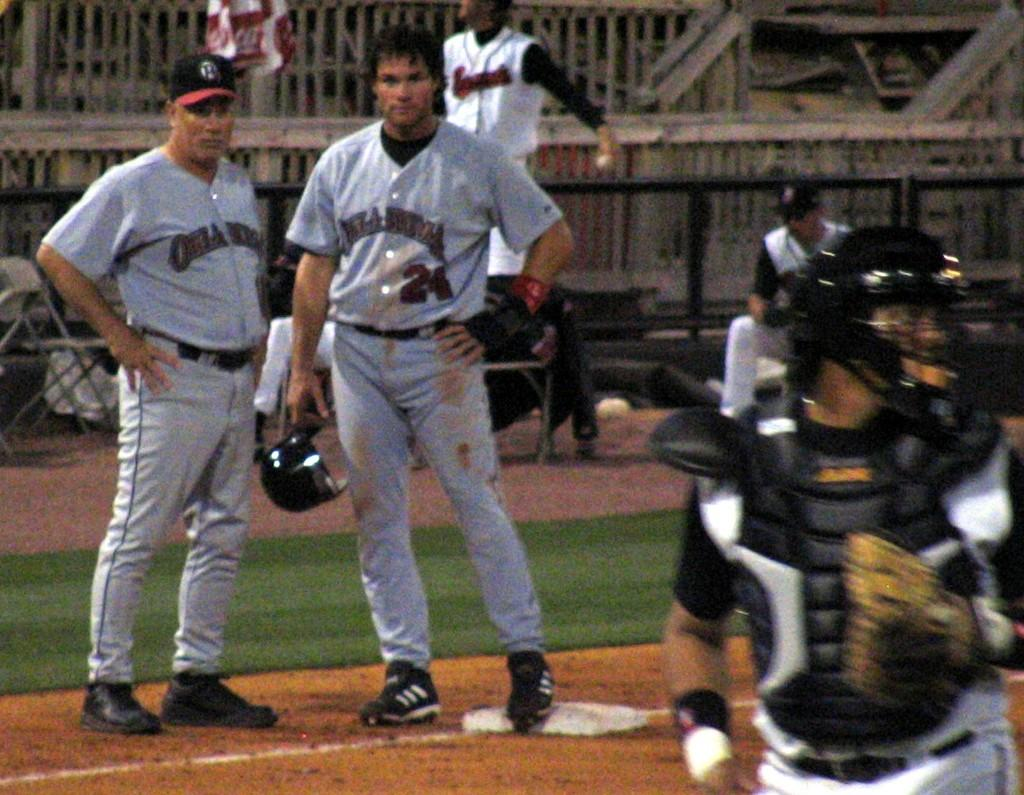<image>
Write a terse but informative summary of the picture. Baseball player wearing number 24 standing with his teammate. 